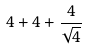<formula> <loc_0><loc_0><loc_500><loc_500>4 + 4 + \frac { 4 } { \sqrt { 4 } }</formula> 